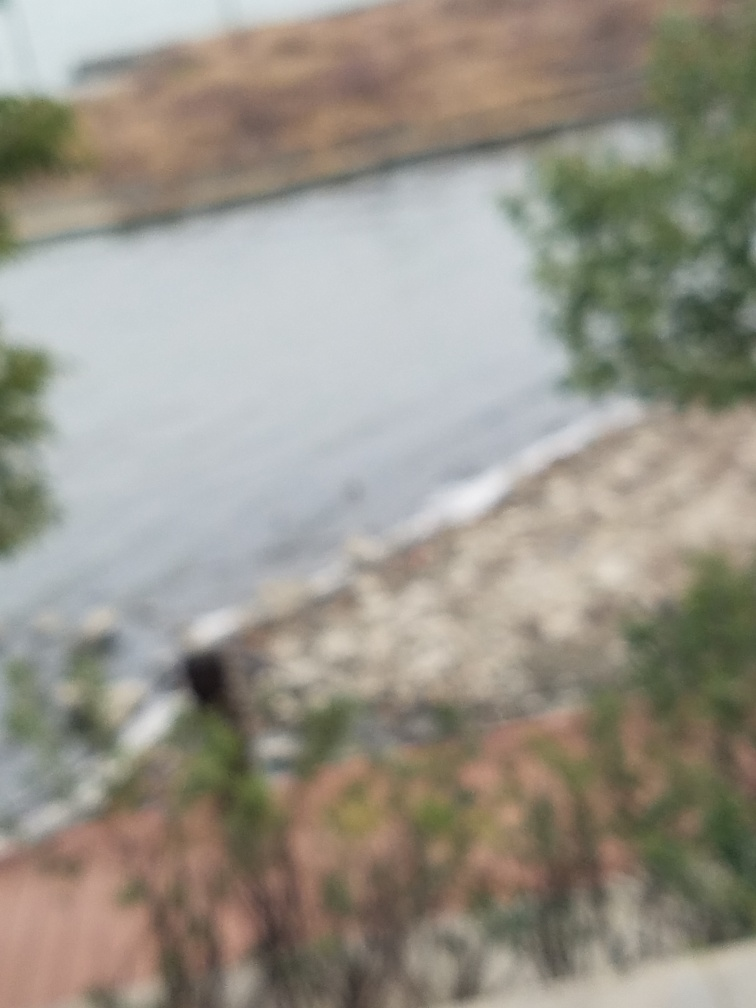Are there any quality issues with this image? Yes, the image is significantly blurred, which affects the clarity and detail that can be observed. It's also possible that it is out of focus or taken with a low-quality camera, as no distinct features are discernible. 